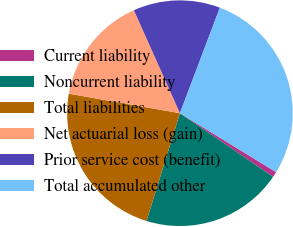<chart> <loc_0><loc_0><loc_500><loc_500><pie_chart><fcel>Current liability<fcel>Noncurrent liability<fcel>Total liabilities<fcel>Net actuarial loss (gain)<fcel>Prior service cost (benefit)<fcel>Total accumulated other<nl><fcel>0.79%<fcel>20.25%<fcel>22.97%<fcel>15.54%<fcel>12.45%<fcel>27.99%<nl></chart> 